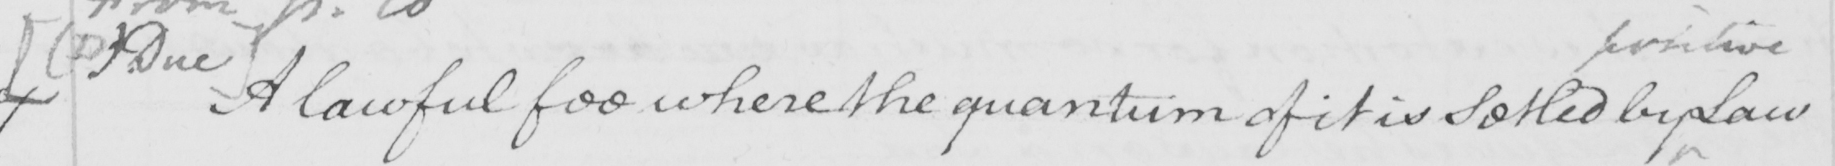What does this handwritten line say? [  ( D )  Due ]  A lawful fee is where the quantum of it is Setled by Law 